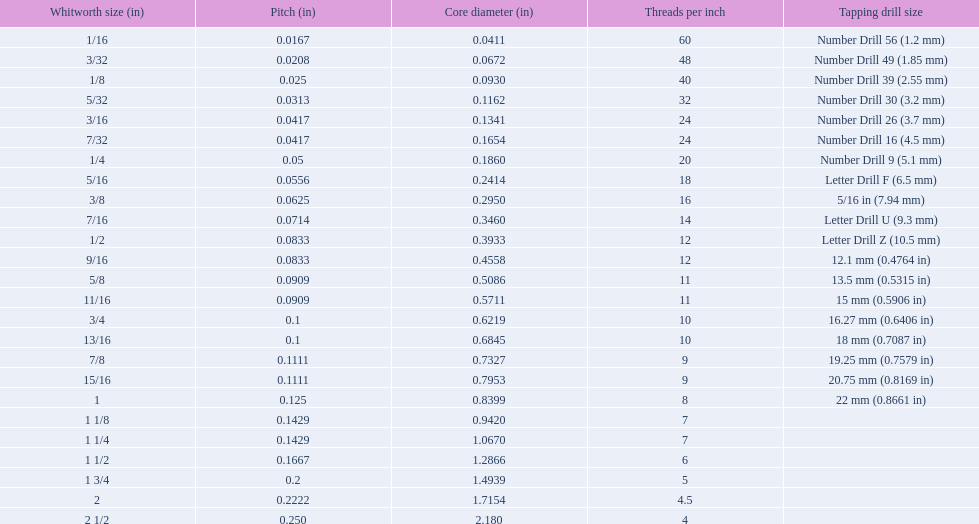What are the whitworth sizes? 1/16, 3/32, 1/8, 5/32, 3/16, 7/32, 1/4, 5/16, 3/8, 7/16, 1/2, 9/16, 5/8, 11/16, 3/4, 13/16, 7/8, 15/16, 1, 1 1/8, 1 1/4, 1 1/2, 1 3/4, 2, 2 1/2. And their threads per inch? 60, 48, 40, 32, 24, 24, 20, 18, 16, 14, 12, 12, 11, 11, 10, 10, 9, 9, 8, 7, 7, 6, 5, 4.5, 4. Now, which whitworth size has a thread-per-inch size of 5?? 1 3/4. 